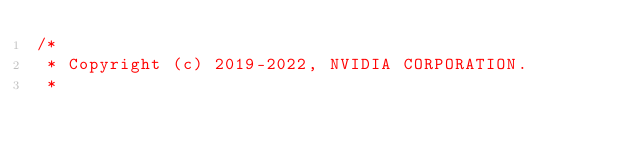Convert code to text. <code><loc_0><loc_0><loc_500><loc_500><_Cuda_>/*
 * Copyright (c) 2019-2022, NVIDIA CORPORATION.
 *</code> 